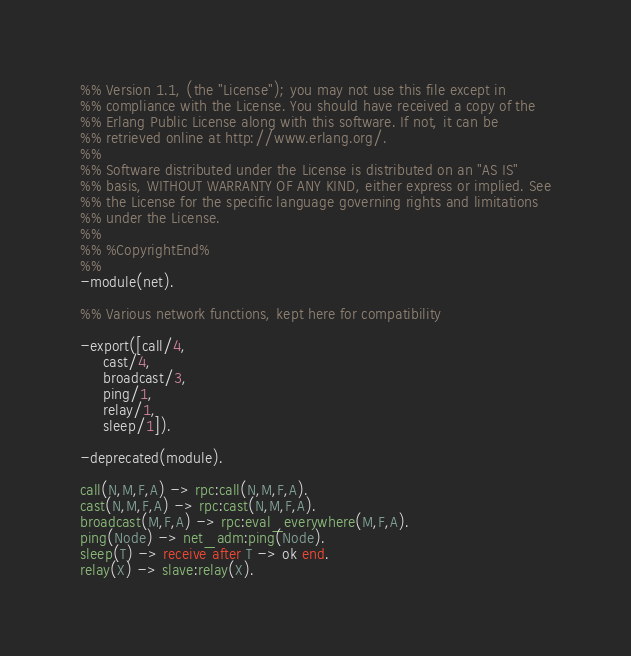Convert code to text. <code><loc_0><loc_0><loc_500><loc_500><_Erlang_>%% Version 1.1, (the "License"); you may not use this file except in
%% compliance with the License. You should have received a copy of the
%% Erlang Public License along with this software. If not, it can be
%% retrieved online at http://www.erlang.org/.
%% 
%% Software distributed under the License is distributed on an "AS IS"
%% basis, WITHOUT WARRANTY OF ANY KIND, either express or implied. See
%% the License for the specific language governing rights and limitations
%% under the License.
%% 
%% %CopyrightEnd%
%%
-module(net).

%% Various network functions, kept here for compatibility

-export([call/4,
	 cast/4,
	 broadcast/3,
	 ping/1,
	 relay/1,
	 sleep/1]).

-deprecated(module).

call(N,M,F,A) -> rpc:call(N,M,F,A).
cast(N,M,F,A) -> rpc:cast(N,M,F,A).
broadcast(M,F,A) -> rpc:eval_everywhere(M,F,A).
ping(Node) -> net_adm:ping(Node).
sleep(T) -> receive after T -> ok end.
relay(X) -> slave:relay(X).


</code> 